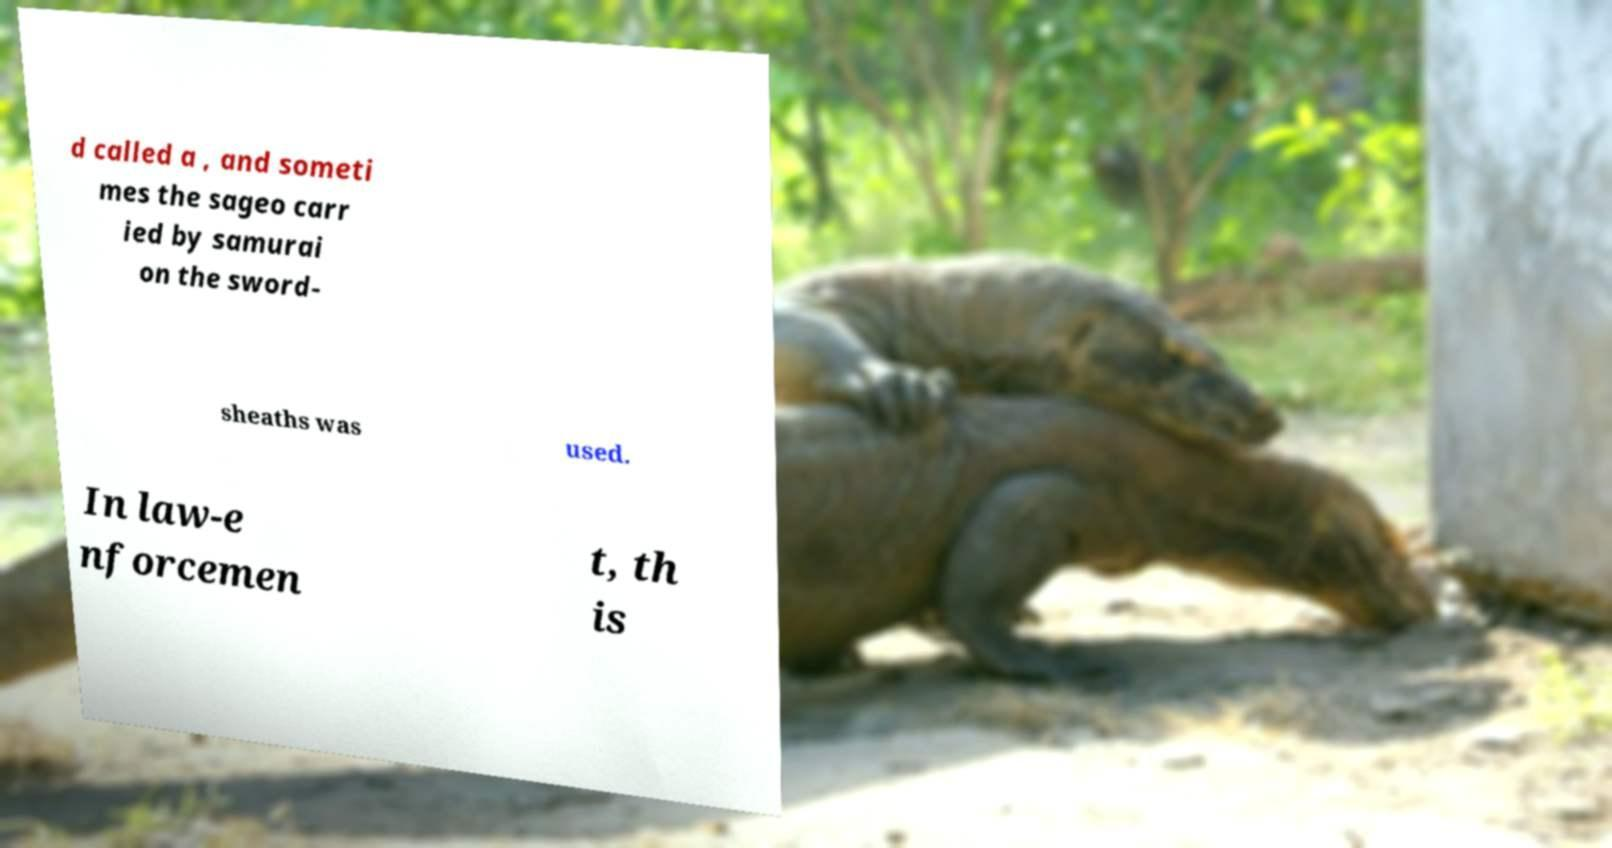Could you assist in decoding the text presented in this image and type it out clearly? d called a , and someti mes the sageo carr ied by samurai on the sword- sheaths was used. In law-e nforcemen t, th is 